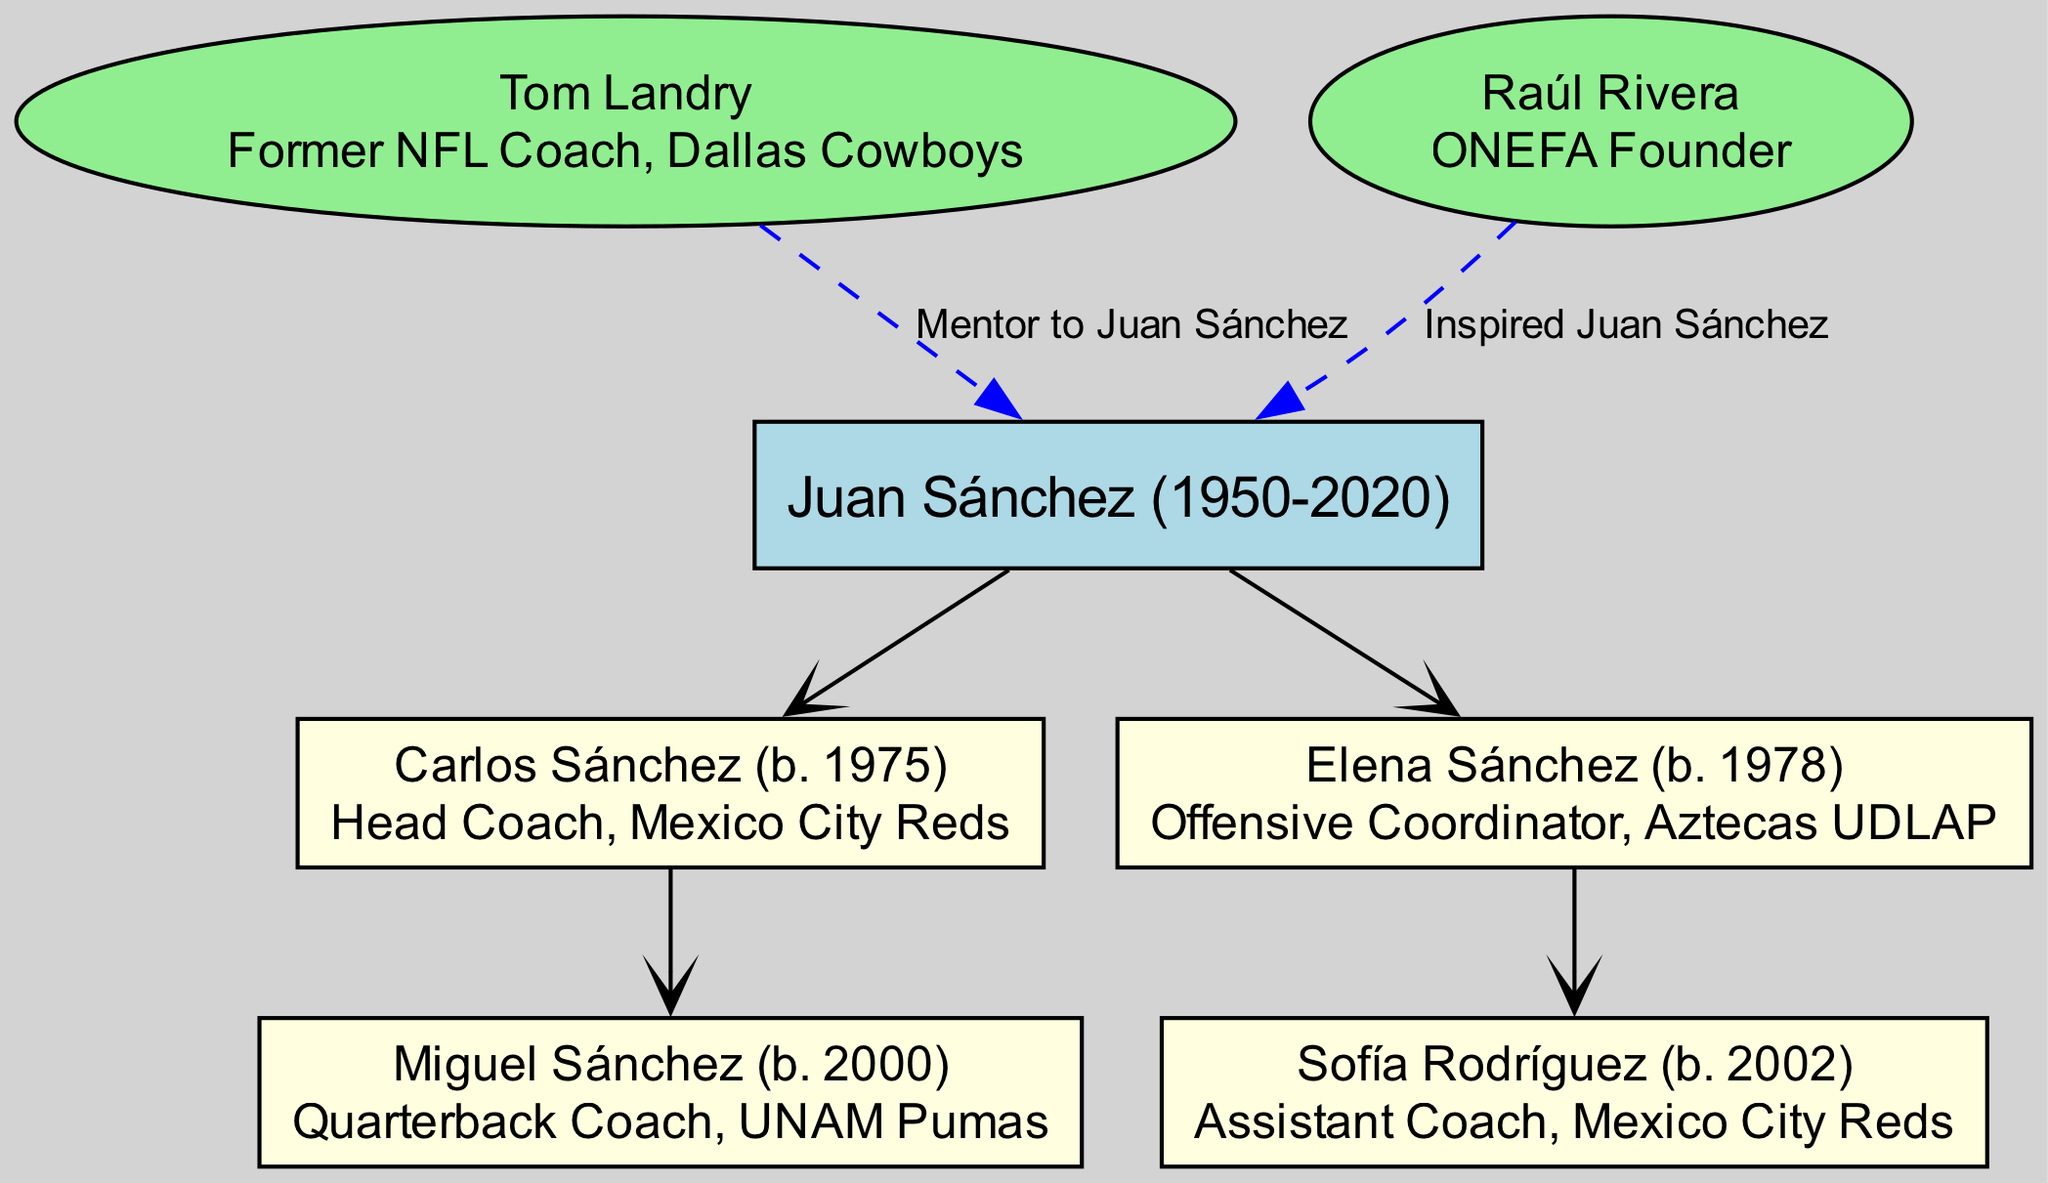What is the name of the root coach in the family tree? The root node is where the family lineage begins. In the provided diagram, the root node is labeled as "Juan Sánchez (1950-2020)," which identifies the starting point of the lineage.
Answer: Juan Sánchez (1950-2020) How many children does Juan Sánchez have? The diagram shows that Juan Sánchez has two children listed under him: Carlos Sánchez and Elena Sánchez. By simply counting these nodes, we find the total number of children.
Answer: 2 What role does Carlos Sánchez hold? By examining the node connected to Carlos Sánchez, the text clearly states "Head Coach, Mexico City Reds," indicating his role within the family lineage.
Answer: Head Coach, Mexico City Reds Who is Sofia Rodríguez's parent? To find the parent of Sofia Rodríguez, we trace the lineage upward from her node. Sofia islisted as a child under Elena Sánchez, illustrating that Elena is her parent.
Answer: Elena Sánchez Which coach was a mentor to Juan Sánchez? The influences section lists a coach named Tom Landry, specifying the connection stating he was a mentor to Juan Sánchez. This connection can be directly identified from the influence nodes.
Answer: Tom Landry How is the relationship between Juan Sánchez and Raúl Rivera characterized? The diagram indicates a relationship through the influence section. It states that Raúl Rivera "Inspired Juan Sánchez," indicating a guiding influence rather than a direct mentorship.
Answer: Inspired Is there any direct sports role held by Miguel Sánchez? By reviewing the role specified under the Miguel Sánchez node, it states "Quarterback Coach, UNAM Pumas." This indicates his specific position within the coaching structure.
Answer: Quarterback Coach, UNAM Pumas What color represents the children nodes in the tree? The child nodes in the diagram are filled with light yellow color. This can be seen visually by examining the child nodes in the diagram.
Answer: Light yellow Who is connected to Juan Sánchez with a dashed line? The diagram shows both Tom Landry and Raúl Rivera connected to Juan Sánchez with dashed lines, indicating an influence relationship. By checking the influences section, one can verify this.
Answer: Tom Landry, Raúl Rivera 